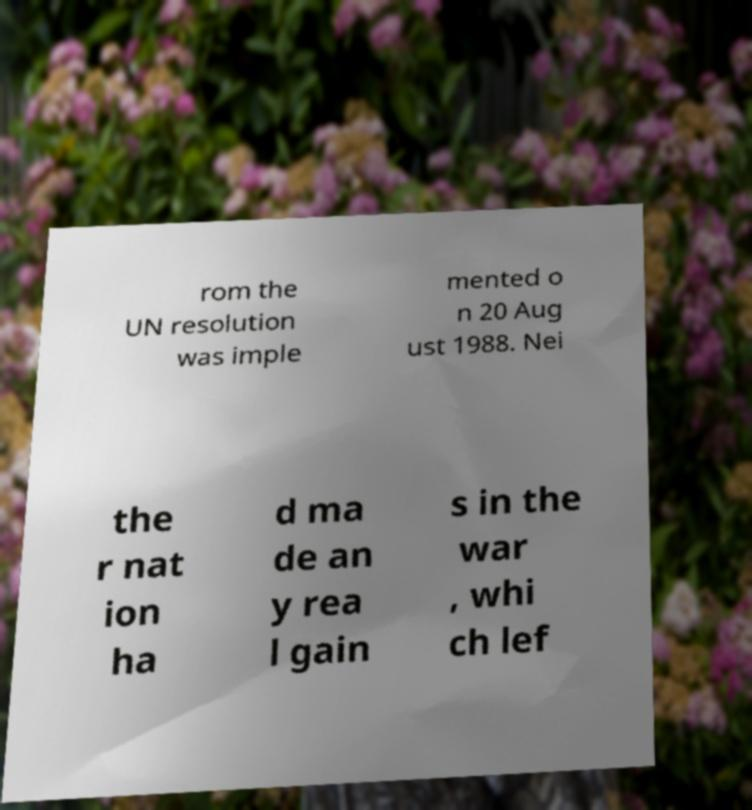Can you read and provide the text displayed in the image?This photo seems to have some interesting text. Can you extract and type it out for me? rom the UN resolution was imple mented o n 20 Aug ust 1988. Nei the r nat ion ha d ma de an y rea l gain s in the war , whi ch lef 